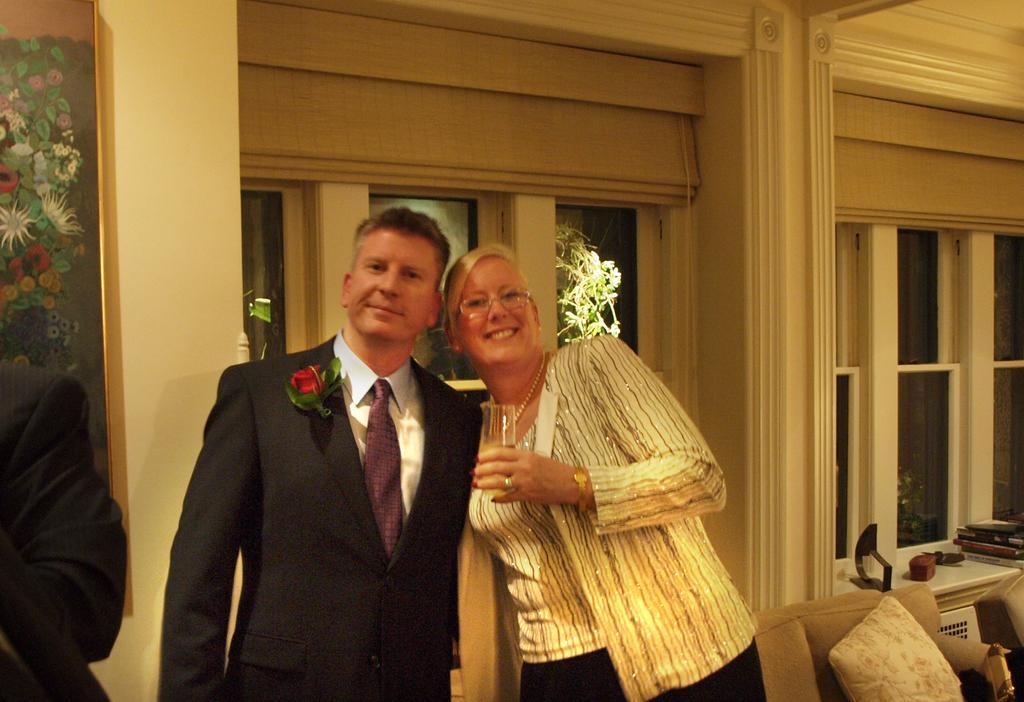In one or two sentences, can you explain what this image depicts? In this image, we can see people and some are wearing coats and we can see a lapel flower on one of the coat and there is a lady holding a glass with drink. In the background, there is a frame on the wall and we can see a cushion on the sofa and there are books and some other objects and we can see curtains and there are windows, through the glass we can see trees. 